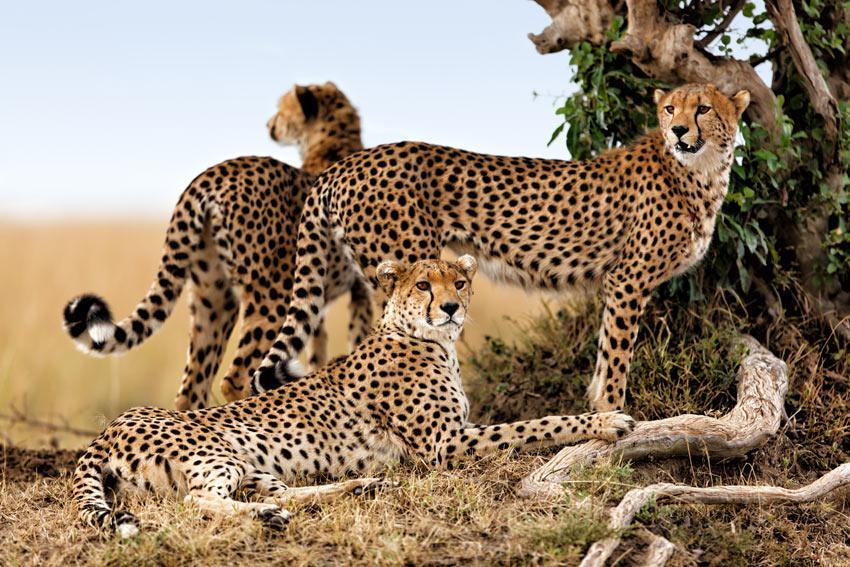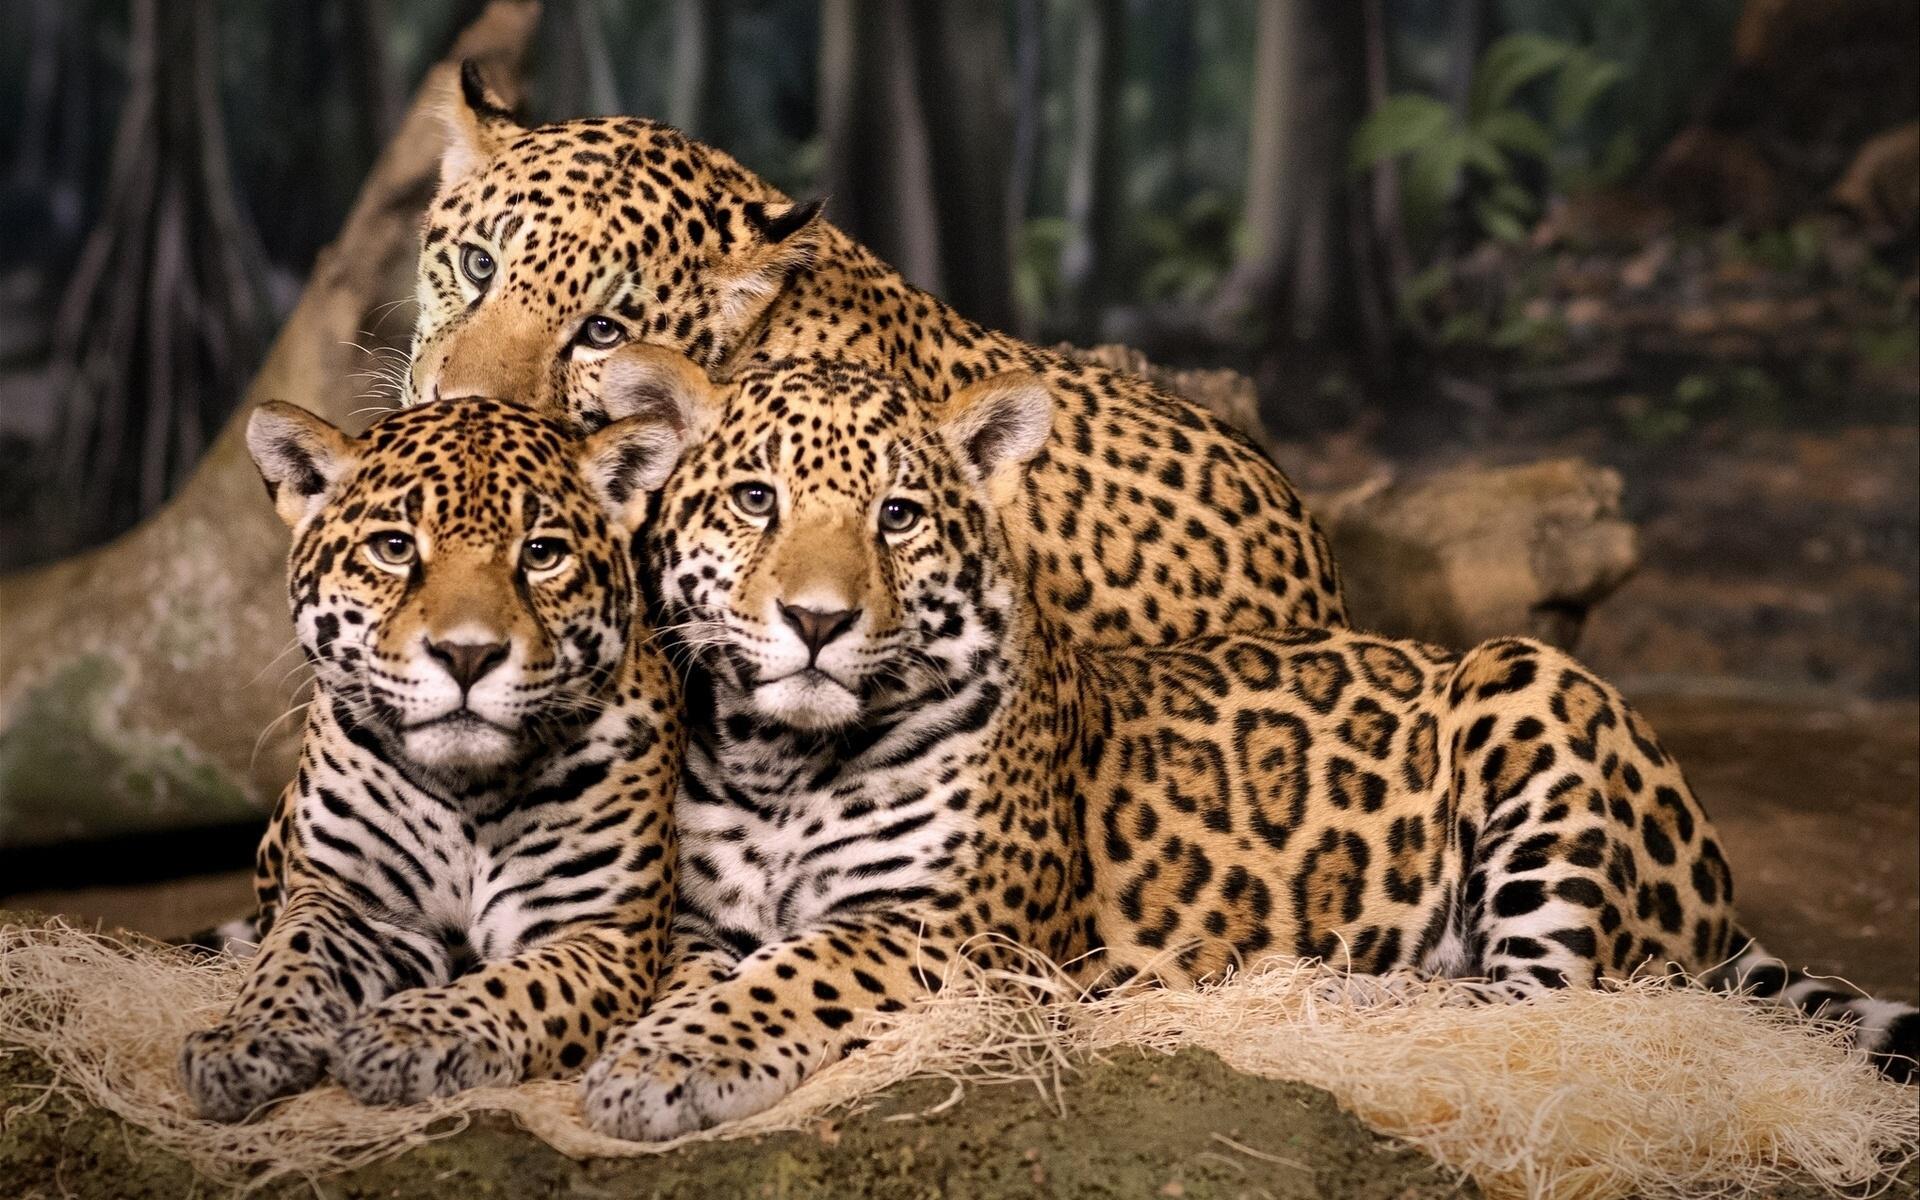The first image is the image on the left, the second image is the image on the right. Given the left and right images, does the statement "There are four leopard’s sitting on a mound of dirt." hold true? Answer yes or no. No. The first image is the image on the left, the second image is the image on the right. For the images displayed, is the sentence "Exactly six of the big cats are resting, keeping an eye on their surroundings." factually correct? Answer yes or no. Yes. 